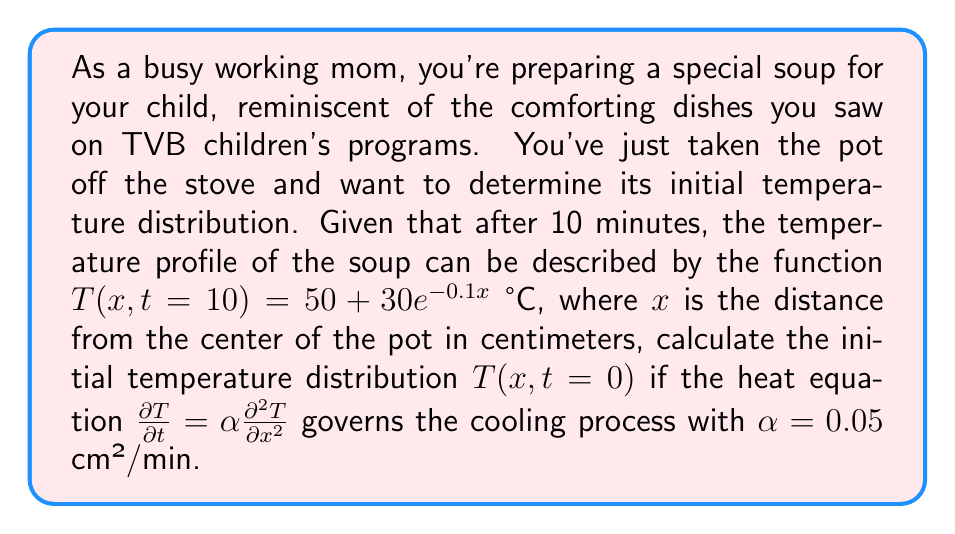Help me with this question. Let's approach this step-by-step:

1) The heat equation is given by:

   $$\frac{\partial T}{\partial t} = \alpha \frac{\partial^2 T}{\partial x^2}$$

2) We're given the temperature profile at t = 10 minutes:

   $$T(x,10) = 50 + 30e^{-0.1x}$$

3) To solve this inverse problem, we can assume that the initial temperature distribution has a similar form:

   $$T(x,0) = A + Be^{-Cx}$$

   where A, B, and C are constants we need to determine.

4) Using the method of separation of variables, we can write the general solution as:

   $$T(x,t) = A + Be^{-Cx}e^{-\alpha C^2t}$$

5) Comparing this with the given temperature profile at t = 10:

   $$50 + 30e^{-0.1x} = A + Be^{-Cx}e^{-0.05C^2(10)}$$

6) This equality should hold for all x, so we can equate the coefficients:

   A = 50
   $30 = Be^{-0.5C^2}$
   C = 0.1

7) Solving for B:

   $$B = 30e^{0.5(0.1)^2} = 30e^{0.005} \approx 30.15$$

8) Therefore, the initial temperature distribution is:

   $$T(x,0) = 50 + 30.15e^{-0.1x}$$
Answer: $T(x,0) = 50 + 30.15e^{-0.1x}$ °C 